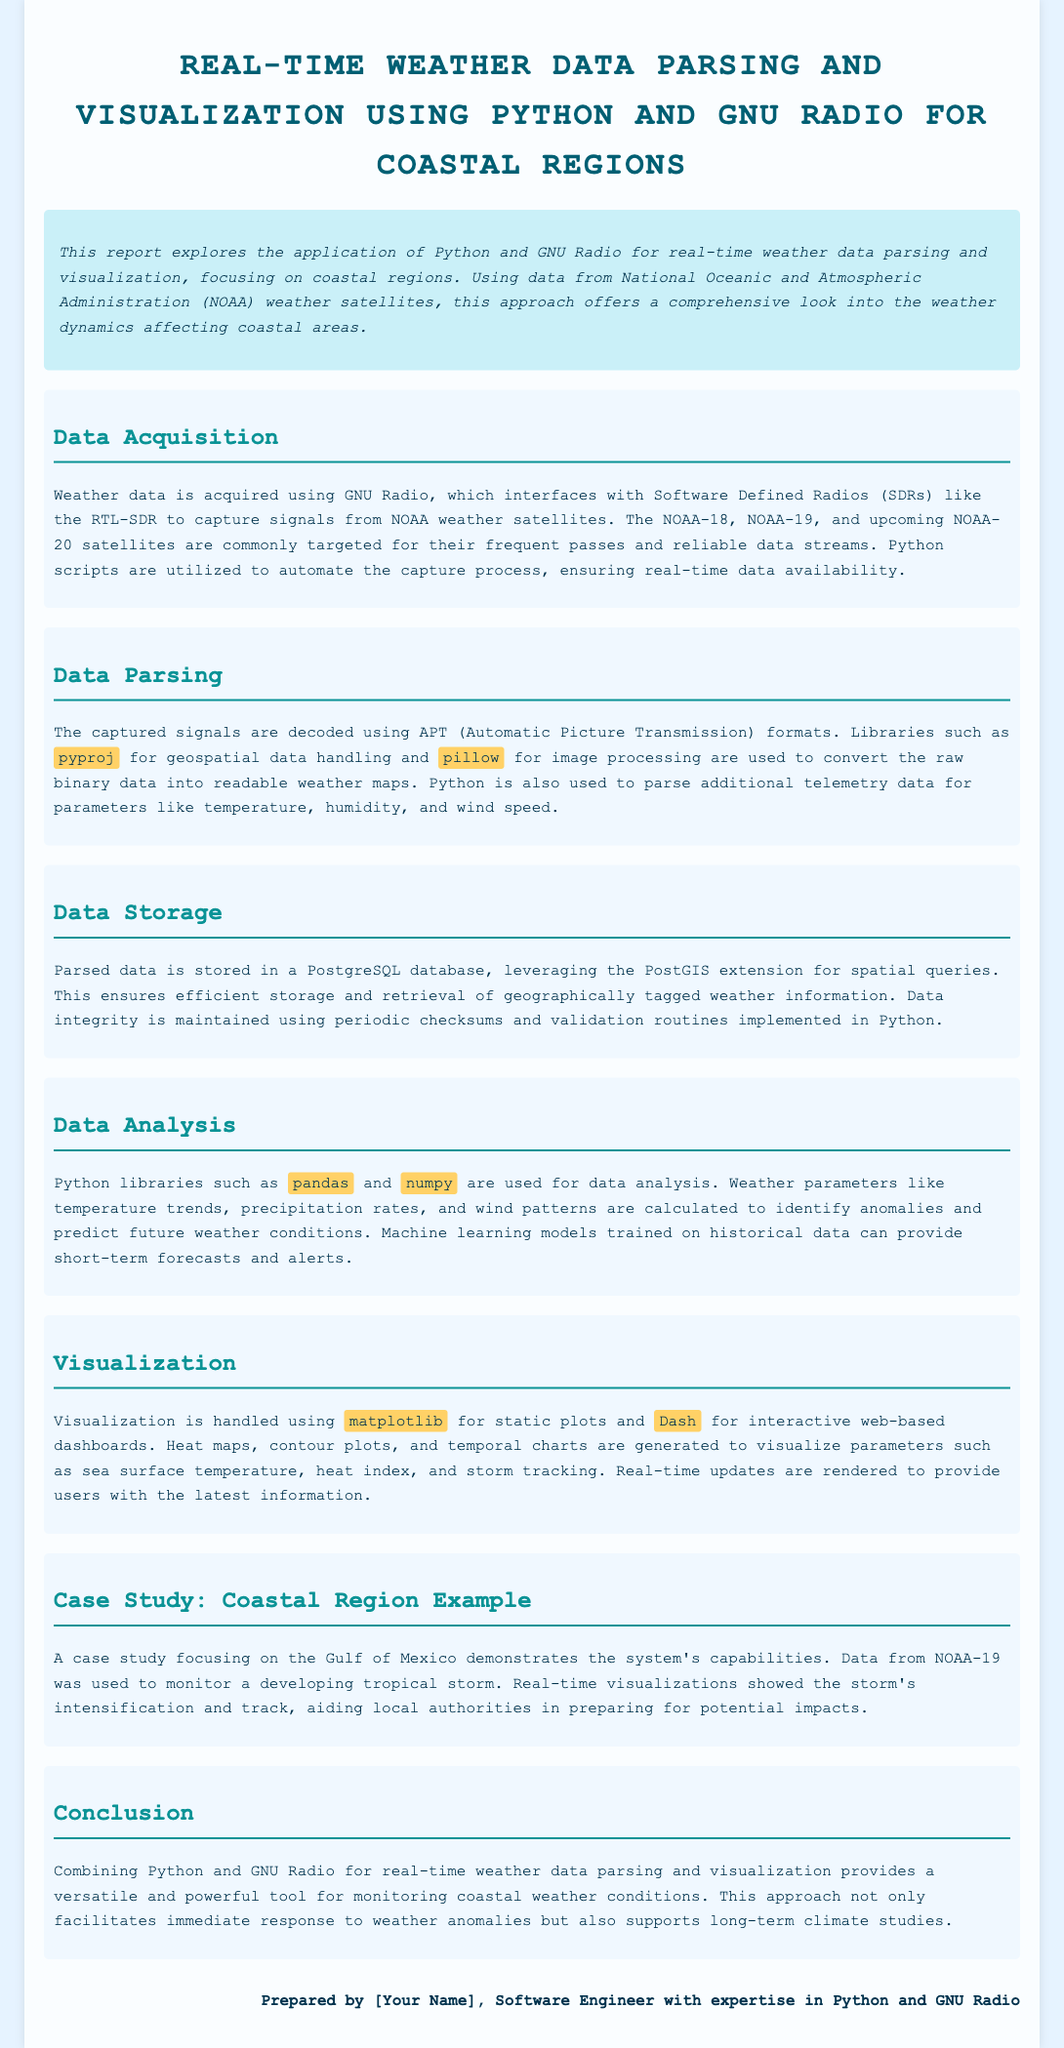What are the key satellites mentioned for weather data acquisition? The document lists NOAA-18, NOAA-19, and NOAA-20 as key satellites for data acquisition.
Answer: NOAA-18, NOAA-19, NOAA-20 Which library is used for image processing in data parsing? The document specifies the use of the library pillow for image processing.
Answer: pillow What is the purpose of using PostGIS in data storage? The document mentions that PostGIS is leveraged for spatial queries to ensure efficient storage and retrieval of geographically tagged weather information.
Answer: Spatial queries What are the main libraries used for data analysis? The document highlights pandas and numpy as the main libraries used for data analysis in the project.
Answer: pandas, numpy What region is the case study focused on? The case study in the document focuses on the Gulf of Mexico as the region of interest.
Answer: Gulf of Mexico What type of visualizations are generated for real-time updates? The document states that heat maps, contour plots, and temporal charts are generated for visualizations.
Answer: Heat maps, contour plots, temporal charts What advantage does combining Python and GNU Radio provide? The document concludes that this combination provides a versatile and powerful tool for monitoring coastal weather conditions.
Answer: Versatile and powerful tool How is real-time data availability ensured? The document explains that Python scripts are utilized to automate the capture process to ensure real-time data availability.
Answer: Automated capture process 